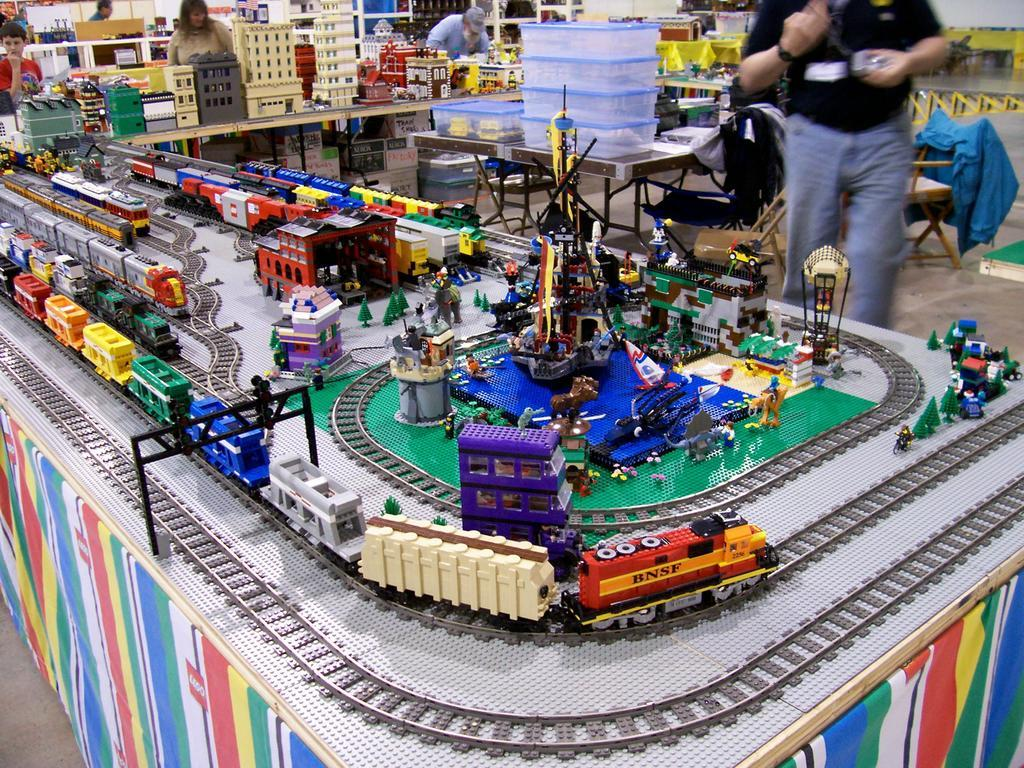What type of establishment is shown in the image? The image depicts a store. What kind of items can be found in the store? There are many toys, boxes, other objects on tables, cars, and clothes in the store. Can you describe the presence of people in the image? Yes, there are people in the store. What type of nerve is responsible for the behavior of the cars in the store? There are no nerves or behaviors mentioned in the image; it simply shows cars among other items in the store. 